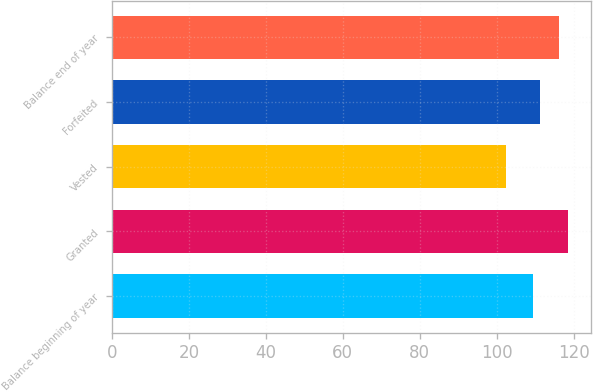Convert chart to OTSL. <chart><loc_0><loc_0><loc_500><loc_500><bar_chart><fcel>Balance beginning of year<fcel>Granted<fcel>Vested<fcel>Forfeited<fcel>Balance end of year<nl><fcel>109.54<fcel>118.63<fcel>102.4<fcel>111.16<fcel>116.32<nl></chart> 